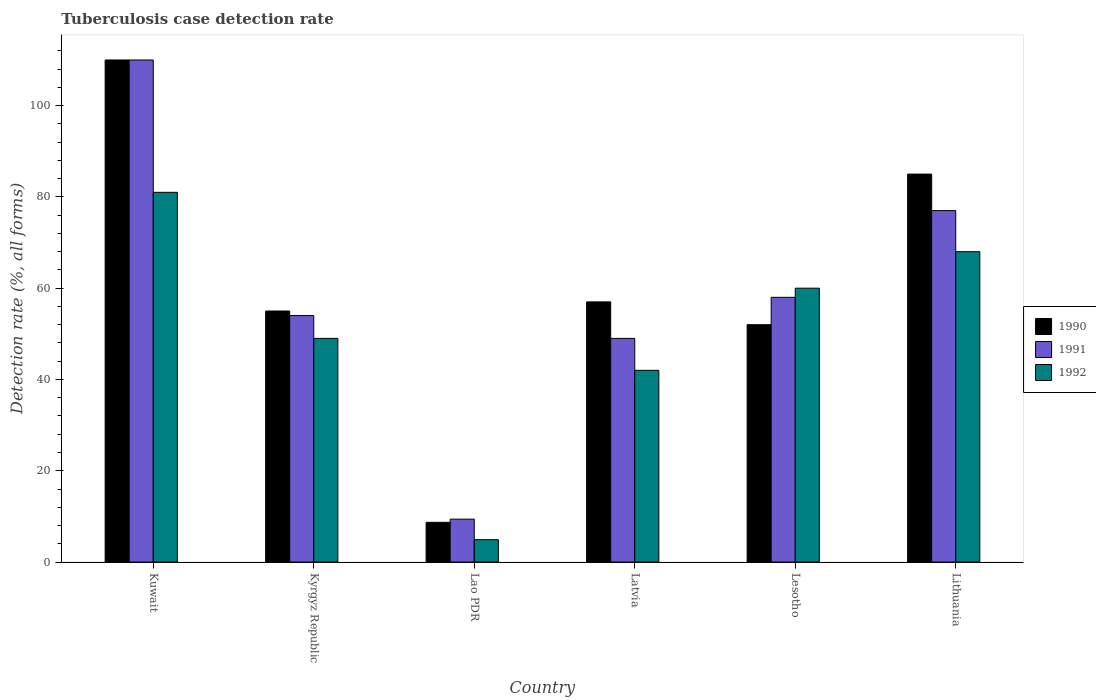How many different coloured bars are there?
Offer a very short reply. 3. How many groups of bars are there?
Your response must be concise. 6. Are the number of bars per tick equal to the number of legend labels?
Offer a very short reply. Yes. Are the number of bars on each tick of the X-axis equal?
Your response must be concise. Yes. How many bars are there on the 3rd tick from the left?
Your response must be concise. 3. How many bars are there on the 6th tick from the right?
Your answer should be compact. 3. What is the label of the 5th group of bars from the left?
Keep it short and to the point. Lesotho. What is the tuberculosis case detection rate in in 1992 in Lithuania?
Provide a short and direct response. 68. Across all countries, what is the maximum tuberculosis case detection rate in in 1990?
Your answer should be compact. 110. In which country was the tuberculosis case detection rate in in 1992 maximum?
Offer a terse response. Kuwait. In which country was the tuberculosis case detection rate in in 1992 minimum?
Ensure brevity in your answer.  Lao PDR. What is the total tuberculosis case detection rate in in 1990 in the graph?
Make the answer very short. 367.7. What is the difference between the tuberculosis case detection rate in in 1991 in Lesotho and the tuberculosis case detection rate in in 1992 in Kuwait?
Ensure brevity in your answer.  -23. What is the average tuberculosis case detection rate in in 1991 per country?
Provide a succinct answer. 59.57. In how many countries, is the tuberculosis case detection rate in in 1992 greater than 64 %?
Provide a short and direct response. 2. What is the ratio of the tuberculosis case detection rate in in 1991 in Lao PDR to that in Lesotho?
Make the answer very short. 0.16. Is the tuberculosis case detection rate in in 1991 in Latvia less than that in Lithuania?
Provide a short and direct response. Yes. What is the difference between the highest and the lowest tuberculosis case detection rate in in 1992?
Ensure brevity in your answer.  76.1. In how many countries, is the tuberculosis case detection rate in in 1991 greater than the average tuberculosis case detection rate in in 1991 taken over all countries?
Make the answer very short. 2. Is the sum of the tuberculosis case detection rate in in 1992 in Kyrgyz Republic and Lithuania greater than the maximum tuberculosis case detection rate in in 1990 across all countries?
Keep it short and to the point. Yes. What does the 3rd bar from the left in Lao PDR represents?
Provide a short and direct response. 1992. What does the 2nd bar from the right in Lithuania represents?
Your response must be concise. 1991. Is it the case that in every country, the sum of the tuberculosis case detection rate in in 1990 and tuberculosis case detection rate in in 1992 is greater than the tuberculosis case detection rate in in 1991?
Your answer should be compact. Yes. Are all the bars in the graph horizontal?
Offer a very short reply. No. What is the difference between two consecutive major ticks on the Y-axis?
Ensure brevity in your answer.  20. How many legend labels are there?
Offer a very short reply. 3. What is the title of the graph?
Ensure brevity in your answer.  Tuberculosis case detection rate. Does "1979" appear as one of the legend labels in the graph?
Ensure brevity in your answer.  No. What is the label or title of the Y-axis?
Provide a short and direct response. Detection rate (%, all forms). What is the Detection rate (%, all forms) in 1990 in Kuwait?
Offer a terse response. 110. What is the Detection rate (%, all forms) in 1991 in Kuwait?
Give a very brief answer. 110. What is the Detection rate (%, all forms) of 1992 in Kuwait?
Provide a short and direct response. 81. What is the Detection rate (%, all forms) in 1990 in Lao PDR?
Your response must be concise. 8.7. What is the Detection rate (%, all forms) of 1991 in Lao PDR?
Your answer should be compact. 9.4. What is the Detection rate (%, all forms) in 1990 in Latvia?
Offer a very short reply. 57. What is the Detection rate (%, all forms) in 1992 in Latvia?
Keep it short and to the point. 42. What is the Detection rate (%, all forms) in 1992 in Lesotho?
Provide a short and direct response. 60. What is the Detection rate (%, all forms) in 1990 in Lithuania?
Offer a terse response. 85. What is the Detection rate (%, all forms) in 1991 in Lithuania?
Your answer should be very brief. 77. Across all countries, what is the maximum Detection rate (%, all forms) of 1990?
Your answer should be very brief. 110. Across all countries, what is the maximum Detection rate (%, all forms) of 1991?
Make the answer very short. 110. Across all countries, what is the minimum Detection rate (%, all forms) in 1990?
Give a very brief answer. 8.7. What is the total Detection rate (%, all forms) of 1990 in the graph?
Ensure brevity in your answer.  367.7. What is the total Detection rate (%, all forms) of 1991 in the graph?
Your answer should be compact. 357.4. What is the total Detection rate (%, all forms) of 1992 in the graph?
Make the answer very short. 304.9. What is the difference between the Detection rate (%, all forms) of 1990 in Kuwait and that in Lao PDR?
Make the answer very short. 101.3. What is the difference between the Detection rate (%, all forms) of 1991 in Kuwait and that in Lao PDR?
Your answer should be compact. 100.6. What is the difference between the Detection rate (%, all forms) in 1992 in Kuwait and that in Lao PDR?
Your answer should be very brief. 76.1. What is the difference between the Detection rate (%, all forms) in 1991 in Kuwait and that in Latvia?
Ensure brevity in your answer.  61. What is the difference between the Detection rate (%, all forms) of 1992 in Kuwait and that in Latvia?
Offer a terse response. 39. What is the difference between the Detection rate (%, all forms) in 1991 in Kuwait and that in Lesotho?
Give a very brief answer. 52. What is the difference between the Detection rate (%, all forms) of 1990 in Kyrgyz Republic and that in Lao PDR?
Provide a short and direct response. 46.3. What is the difference between the Detection rate (%, all forms) of 1991 in Kyrgyz Republic and that in Lao PDR?
Provide a short and direct response. 44.6. What is the difference between the Detection rate (%, all forms) of 1992 in Kyrgyz Republic and that in Lao PDR?
Provide a succinct answer. 44.1. What is the difference between the Detection rate (%, all forms) of 1990 in Kyrgyz Republic and that in Latvia?
Offer a very short reply. -2. What is the difference between the Detection rate (%, all forms) in 1991 in Kyrgyz Republic and that in Lithuania?
Your answer should be compact. -23. What is the difference between the Detection rate (%, all forms) of 1992 in Kyrgyz Republic and that in Lithuania?
Ensure brevity in your answer.  -19. What is the difference between the Detection rate (%, all forms) of 1990 in Lao PDR and that in Latvia?
Provide a succinct answer. -48.3. What is the difference between the Detection rate (%, all forms) of 1991 in Lao PDR and that in Latvia?
Your response must be concise. -39.6. What is the difference between the Detection rate (%, all forms) of 1992 in Lao PDR and that in Latvia?
Your response must be concise. -37.1. What is the difference between the Detection rate (%, all forms) of 1990 in Lao PDR and that in Lesotho?
Make the answer very short. -43.3. What is the difference between the Detection rate (%, all forms) in 1991 in Lao PDR and that in Lesotho?
Offer a terse response. -48.6. What is the difference between the Detection rate (%, all forms) in 1992 in Lao PDR and that in Lesotho?
Make the answer very short. -55.1. What is the difference between the Detection rate (%, all forms) of 1990 in Lao PDR and that in Lithuania?
Ensure brevity in your answer.  -76.3. What is the difference between the Detection rate (%, all forms) in 1991 in Lao PDR and that in Lithuania?
Provide a succinct answer. -67.6. What is the difference between the Detection rate (%, all forms) in 1992 in Lao PDR and that in Lithuania?
Make the answer very short. -63.1. What is the difference between the Detection rate (%, all forms) in 1990 in Latvia and that in Lesotho?
Keep it short and to the point. 5. What is the difference between the Detection rate (%, all forms) of 1991 in Latvia and that in Lesotho?
Ensure brevity in your answer.  -9. What is the difference between the Detection rate (%, all forms) of 1990 in Latvia and that in Lithuania?
Make the answer very short. -28. What is the difference between the Detection rate (%, all forms) of 1992 in Latvia and that in Lithuania?
Provide a succinct answer. -26. What is the difference between the Detection rate (%, all forms) in 1990 in Lesotho and that in Lithuania?
Offer a very short reply. -33. What is the difference between the Detection rate (%, all forms) in 1991 in Lesotho and that in Lithuania?
Your answer should be compact. -19. What is the difference between the Detection rate (%, all forms) of 1992 in Lesotho and that in Lithuania?
Your answer should be compact. -8. What is the difference between the Detection rate (%, all forms) of 1990 in Kuwait and the Detection rate (%, all forms) of 1992 in Kyrgyz Republic?
Keep it short and to the point. 61. What is the difference between the Detection rate (%, all forms) in 1990 in Kuwait and the Detection rate (%, all forms) in 1991 in Lao PDR?
Your answer should be very brief. 100.6. What is the difference between the Detection rate (%, all forms) in 1990 in Kuwait and the Detection rate (%, all forms) in 1992 in Lao PDR?
Your response must be concise. 105.1. What is the difference between the Detection rate (%, all forms) of 1991 in Kuwait and the Detection rate (%, all forms) of 1992 in Lao PDR?
Keep it short and to the point. 105.1. What is the difference between the Detection rate (%, all forms) in 1990 in Kuwait and the Detection rate (%, all forms) in 1991 in Latvia?
Provide a short and direct response. 61. What is the difference between the Detection rate (%, all forms) in 1990 in Kuwait and the Detection rate (%, all forms) in 1992 in Latvia?
Provide a short and direct response. 68. What is the difference between the Detection rate (%, all forms) in 1991 in Kuwait and the Detection rate (%, all forms) in 1992 in Latvia?
Your answer should be very brief. 68. What is the difference between the Detection rate (%, all forms) in 1990 in Kuwait and the Detection rate (%, all forms) in 1992 in Lesotho?
Your response must be concise. 50. What is the difference between the Detection rate (%, all forms) of 1991 in Kuwait and the Detection rate (%, all forms) of 1992 in Lesotho?
Offer a terse response. 50. What is the difference between the Detection rate (%, all forms) in 1990 in Kuwait and the Detection rate (%, all forms) in 1992 in Lithuania?
Offer a terse response. 42. What is the difference between the Detection rate (%, all forms) of 1991 in Kuwait and the Detection rate (%, all forms) of 1992 in Lithuania?
Give a very brief answer. 42. What is the difference between the Detection rate (%, all forms) in 1990 in Kyrgyz Republic and the Detection rate (%, all forms) in 1991 in Lao PDR?
Make the answer very short. 45.6. What is the difference between the Detection rate (%, all forms) in 1990 in Kyrgyz Republic and the Detection rate (%, all forms) in 1992 in Lao PDR?
Provide a short and direct response. 50.1. What is the difference between the Detection rate (%, all forms) in 1991 in Kyrgyz Republic and the Detection rate (%, all forms) in 1992 in Lao PDR?
Ensure brevity in your answer.  49.1. What is the difference between the Detection rate (%, all forms) of 1990 in Kyrgyz Republic and the Detection rate (%, all forms) of 1991 in Latvia?
Your response must be concise. 6. What is the difference between the Detection rate (%, all forms) of 1990 in Kyrgyz Republic and the Detection rate (%, all forms) of 1992 in Latvia?
Ensure brevity in your answer.  13. What is the difference between the Detection rate (%, all forms) in 1991 in Kyrgyz Republic and the Detection rate (%, all forms) in 1992 in Latvia?
Offer a terse response. 12. What is the difference between the Detection rate (%, all forms) in 1990 in Kyrgyz Republic and the Detection rate (%, all forms) in 1992 in Lesotho?
Ensure brevity in your answer.  -5. What is the difference between the Detection rate (%, all forms) in 1991 in Kyrgyz Republic and the Detection rate (%, all forms) in 1992 in Lesotho?
Keep it short and to the point. -6. What is the difference between the Detection rate (%, all forms) in 1990 in Kyrgyz Republic and the Detection rate (%, all forms) in 1991 in Lithuania?
Your response must be concise. -22. What is the difference between the Detection rate (%, all forms) of 1990 in Kyrgyz Republic and the Detection rate (%, all forms) of 1992 in Lithuania?
Your answer should be compact. -13. What is the difference between the Detection rate (%, all forms) of 1991 in Kyrgyz Republic and the Detection rate (%, all forms) of 1992 in Lithuania?
Your answer should be compact. -14. What is the difference between the Detection rate (%, all forms) of 1990 in Lao PDR and the Detection rate (%, all forms) of 1991 in Latvia?
Offer a terse response. -40.3. What is the difference between the Detection rate (%, all forms) in 1990 in Lao PDR and the Detection rate (%, all forms) in 1992 in Latvia?
Your answer should be very brief. -33.3. What is the difference between the Detection rate (%, all forms) in 1991 in Lao PDR and the Detection rate (%, all forms) in 1992 in Latvia?
Your answer should be compact. -32.6. What is the difference between the Detection rate (%, all forms) of 1990 in Lao PDR and the Detection rate (%, all forms) of 1991 in Lesotho?
Provide a short and direct response. -49.3. What is the difference between the Detection rate (%, all forms) in 1990 in Lao PDR and the Detection rate (%, all forms) in 1992 in Lesotho?
Keep it short and to the point. -51.3. What is the difference between the Detection rate (%, all forms) in 1991 in Lao PDR and the Detection rate (%, all forms) in 1992 in Lesotho?
Your response must be concise. -50.6. What is the difference between the Detection rate (%, all forms) in 1990 in Lao PDR and the Detection rate (%, all forms) in 1991 in Lithuania?
Make the answer very short. -68.3. What is the difference between the Detection rate (%, all forms) of 1990 in Lao PDR and the Detection rate (%, all forms) of 1992 in Lithuania?
Your response must be concise. -59.3. What is the difference between the Detection rate (%, all forms) in 1991 in Lao PDR and the Detection rate (%, all forms) in 1992 in Lithuania?
Make the answer very short. -58.6. What is the difference between the Detection rate (%, all forms) of 1991 in Latvia and the Detection rate (%, all forms) of 1992 in Lithuania?
Your answer should be very brief. -19. What is the difference between the Detection rate (%, all forms) of 1990 in Lesotho and the Detection rate (%, all forms) of 1991 in Lithuania?
Offer a very short reply. -25. What is the difference between the Detection rate (%, all forms) in 1990 in Lesotho and the Detection rate (%, all forms) in 1992 in Lithuania?
Provide a short and direct response. -16. What is the average Detection rate (%, all forms) in 1990 per country?
Provide a succinct answer. 61.28. What is the average Detection rate (%, all forms) of 1991 per country?
Provide a short and direct response. 59.57. What is the average Detection rate (%, all forms) of 1992 per country?
Offer a terse response. 50.82. What is the difference between the Detection rate (%, all forms) of 1990 and Detection rate (%, all forms) of 1992 in Kuwait?
Your response must be concise. 29. What is the difference between the Detection rate (%, all forms) in 1990 and Detection rate (%, all forms) in 1991 in Kyrgyz Republic?
Give a very brief answer. 1. What is the difference between the Detection rate (%, all forms) of 1990 and Detection rate (%, all forms) of 1992 in Kyrgyz Republic?
Keep it short and to the point. 6. What is the difference between the Detection rate (%, all forms) of 1990 and Detection rate (%, all forms) of 1992 in Lao PDR?
Make the answer very short. 3.8. What is the difference between the Detection rate (%, all forms) of 1990 and Detection rate (%, all forms) of 1991 in Latvia?
Keep it short and to the point. 8. What is the difference between the Detection rate (%, all forms) in 1990 and Detection rate (%, all forms) in 1992 in Latvia?
Ensure brevity in your answer.  15. What is the difference between the Detection rate (%, all forms) of 1990 and Detection rate (%, all forms) of 1991 in Lesotho?
Your response must be concise. -6. What is the difference between the Detection rate (%, all forms) of 1991 and Detection rate (%, all forms) of 1992 in Lesotho?
Ensure brevity in your answer.  -2. What is the difference between the Detection rate (%, all forms) of 1990 and Detection rate (%, all forms) of 1991 in Lithuania?
Provide a short and direct response. 8. What is the difference between the Detection rate (%, all forms) in 1991 and Detection rate (%, all forms) in 1992 in Lithuania?
Provide a succinct answer. 9. What is the ratio of the Detection rate (%, all forms) of 1991 in Kuwait to that in Kyrgyz Republic?
Ensure brevity in your answer.  2.04. What is the ratio of the Detection rate (%, all forms) in 1992 in Kuwait to that in Kyrgyz Republic?
Give a very brief answer. 1.65. What is the ratio of the Detection rate (%, all forms) of 1990 in Kuwait to that in Lao PDR?
Keep it short and to the point. 12.64. What is the ratio of the Detection rate (%, all forms) in 1991 in Kuwait to that in Lao PDR?
Give a very brief answer. 11.7. What is the ratio of the Detection rate (%, all forms) in 1992 in Kuwait to that in Lao PDR?
Your answer should be compact. 16.53. What is the ratio of the Detection rate (%, all forms) in 1990 in Kuwait to that in Latvia?
Your answer should be compact. 1.93. What is the ratio of the Detection rate (%, all forms) of 1991 in Kuwait to that in Latvia?
Provide a short and direct response. 2.24. What is the ratio of the Detection rate (%, all forms) in 1992 in Kuwait to that in Latvia?
Ensure brevity in your answer.  1.93. What is the ratio of the Detection rate (%, all forms) in 1990 in Kuwait to that in Lesotho?
Your answer should be compact. 2.12. What is the ratio of the Detection rate (%, all forms) in 1991 in Kuwait to that in Lesotho?
Offer a terse response. 1.9. What is the ratio of the Detection rate (%, all forms) of 1992 in Kuwait to that in Lesotho?
Give a very brief answer. 1.35. What is the ratio of the Detection rate (%, all forms) of 1990 in Kuwait to that in Lithuania?
Provide a short and direct response. 1.29. What is the ratio of the Detection rate (%, all forms) of 1991 in Kuwait to that in Lithuania?
Your response must be concise. 1.43. What is the ratio of the Detection rate (%, all forms) of 1992 in Kuwait to that in Lithuania?
Offer a terse response. 1.19. What is the ratio of the Detection rate (%, all forms) in 1990 in Kyrgyz Republic to that in Lao PDR?
Your answer should be compact. 6.32. What is the ratio of the Detection rate (%, all forms) of 1991 in Kyrgyz Republic to that in Lao PDR?
Give a very brief answer. 5.74. What is the ratio of the Detection rate (%, all forms) in 1992 in Kyrgyz Republic to that in Lao PDR?
Provide a succinct answer. 10. What is the ratio of the Detection rate (%, all forms) of 1990 in Kyrgyz Republic to that in Latvia?
Make the answer very short. 0.96. What is the ratio of the Detection rate (%, all forms) of 1991 in Kyrgyz Republic to that in Latvia?
Your answer should be very brief. 1.1. What is the ratio of the Detection rate (%, all forms) of 1990 in Kyrgyz Republic to that in Lesotho?
Offer a terse response. 1.06. What is the ratio of the Detection rate (%, all forms) in 1992 in Kyrgyz Republic to that in Lesotho?
Offer a very short reply. 0.82. What is the ratio of the Detection rate (%, all forms) in 1990 in Kyrgyz Republic to that in Lithuania?
Provide a succinct answer. 0.65. What is the ratio of the Detection rate (%, all forms) in 1991 in Kyrgyz Republic to that in Lithuania?
Ensure brevity in your answer.  0.7. What is the ratio of the Detection rate (%, all forms) in 1992 in Kyrgyz Republic to that in Lithuania?
Offer a terse response. 0.72. What is the ratio of the Detection rate (%, all forms) in 1990 in Lao PDR to that in Latvia?
Offer a terse response. 0.15. What is the ratio of the Detection rate (%, all forms) in 1991 in Lao PDR to that in Latvia?
Your answer should be very brief. 0.19. What is the ratio of the Detection rate (%, all forms) of 1992 in Lao PDR to that in Latvia?
Your response must be concise. 0.12. What is the ratio of the Detection rate (%, all forms) of 1990 in Lao PDR to that in Lesotho?
Provide a short and direct response. 0.17. What is the ratio of the Detection rate (%, all forms) of 1991 in Lao PDR to that in Lesotho?
Provide a succinct answer. 0.16. What is the ratio of the Detection rate (%, all forms) of 1992 in Lao PDR to that in Lesotho?
Offer a terse response. 0.08. What is the ratio of the Detection rate (%, all forms) in 1990 in Lao PDR to that in Lithuania?
Provide a succinct answer. 0.1. What is the ratio of the Detection rate (%, all forms) of 1991 in Lao PDR to that in Lithuania?
Provide a succinct answer. 0.12. What is the ratio of the Detection rate (%, all forms) of 1992 in Lao PDR to that in Lithuania?
Offer a very short reply. 0.07. What is the ratio of the Detection rate (%, all forms) of 1990 in Latvia to that in Lesotho?
Your answer should be very brief. 1.1. What is the ratio of the Detection rate (%, all forms) of 1991 in Latvia to that in Lesotho?
Offer a very short reply. 0.84. What is the ratio of the Detection rate (%, all forms) in 1990 in Latvia to that in Lithuania?
Offer a very short reply. 0.67. What is the ratio of the Detection rate (%, all forms) of 1991 in Latvia to that in Lithuania?
Offer a very short reply. 0.64. What is the ratio of the Detection rate (%, all forms) of 1992 in Latvia to that in Lithuania?
Give a very brief answer. 0.62. What is the ratio of the Detection rate (%, all forms) in 1990 in Lesotho to that in Lithuania?
Keep it short and to the point. 0.61. What is the ratio of the Detection rate (%, all forms) of 1991 in Lesotho to that in Lithuania?
Give a very brief answer. 0.75. What is the ratio of the Detection rate (%, all forms) in 1992 in Lesotho to that in Lithuania?
Offer a terse response. 0.88. What is the difference between the highest and the second highest Detection rate (%, all forms) in 1990?
Offer a very short reply. 25. What is the difference between the highest and the second highest Detection rate (%, all forms) in 1991?
Provide a short and direct response. 33. What is the difference between the highest and the lowest Detection rate (%, all forms) in 1990?
Ensure brevity in your answer.  101.3. What is the difference between the highest and the lowest Detection rate (%, all forms) of 1991?
Provide a succinct answer. 100.6. What is the difference between the highest and the lowest Detection rate (%, all forms) in 1992?
Your answer should be very brief. 76.1. 